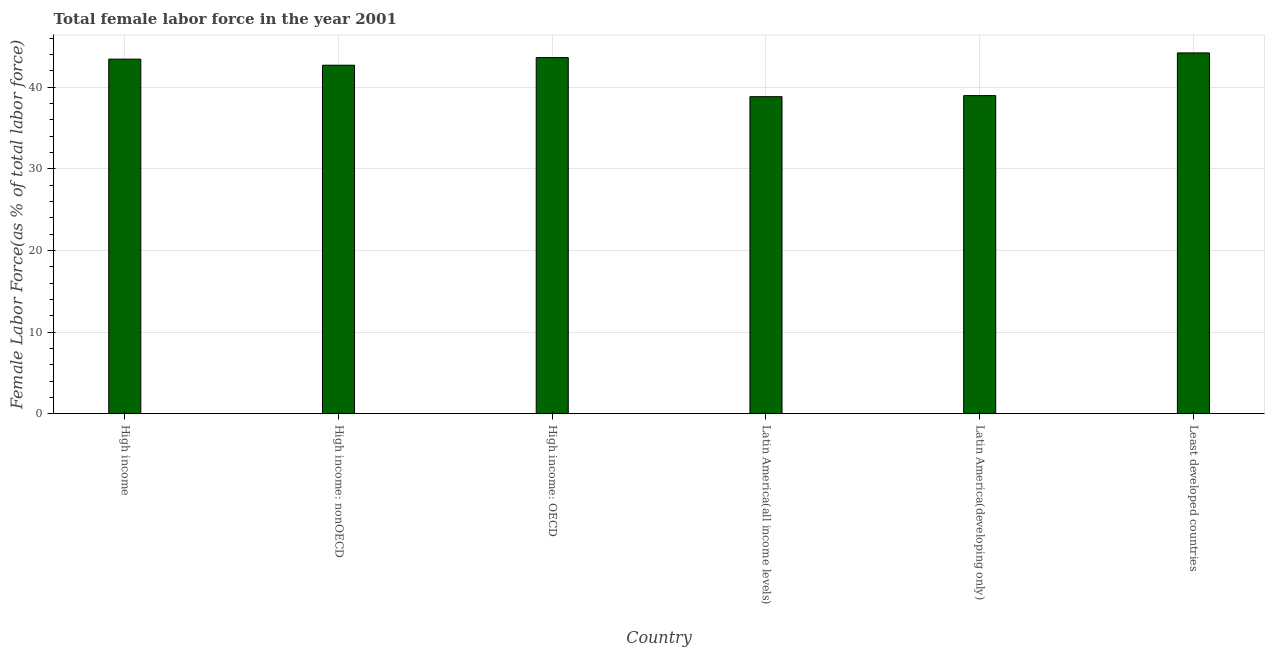Does the graph contain any zero values?
Your answer should be compact. No. What is the title of the graph?
Give a very brief answer. Total female labor force in the year 2001. What is the label or title of the Y-axis?
Provide a short and direct response. Female Labor Force(as % of total labor force). What is the total female labor force in Least developed countries?
Provide a short and direct response. 44.21. Across all countries, what is the maximum total female labor force?
Offer a very short reply. 44.21. Across all countries, what is the minimum total female labor force?
Provide a succinct answer. 38.84. In which country was the total female labor force maximum?
Your answer should be very brief. Least developed countries. In which country was the total female labor force minimum?
Your answer should be very brief. Latin America(all income levels). What is the sum of the total female labor force?
Make the answer very short. 251.8. What is the difference between the total female labor force in High income and Latin America(all income levels)?
Offer a very short reply. 4.6. What is the average total female labor force per country?
Provide a short and direct response. 41.97. What is the median total female labor force?
Make the answer very short. 43.07. Is the difference between the total female labor force in High income and High income: nonOECD greater than the difference between any two countries?
Give a very brief answer. No. What is the difference between the highest and the second highest total female labor force?
Offer a very short reply. 0.57. What is the difference between the highest and the lowest total female labor force?
Provide a short and direct response. 5.36. How many countries are there in the graph?
Offer a terse response. 6. What is the difference between two consecutive major ticks on the Y-axis?
Provide a short and direct response. 10. Are the values on the major ticks of Y-axis written in scientific E-notation?
Your response must be concise. No. What is the Female Labor Force(as % of total labor force) of High income?
Provide a succinct answer. 43.44. What is the Female Labor Force(as % of total labor force) in High income: nonOECD?
Your answer should be compact. 42.7. What is the Female Labor Force(as % of total labor force) of High income: OECD?
Give a very brief answer. 43.63. What is the Female Labor Force(as % of total labor force) of Latin America(all income levels)?
Provide a succinct answer. 38.84. What is the Female Labor Force(as % of total labor force) in Latin America(developing only)?
Give a very brief answer. 38.97. What is the Female Labor Force(as % of total labor force) in Least developed countries?
Ensure brevity in your answer.  44.21. What is the difference between the Female Labor Force(as % of total labor force) in High income and High income: nonOECD?
Offer a very short reply. 0.74. What is the difference between the Female Labor Force(as % of total labor force) in High income and High income: OECD?
Offer a terse response. -0.19. What is the difference between the Female Labor Force(as % of total labor force) in High income and Latin America(all income levels)?
Your response must be concise. 4.6. What is the difference between the Female Labor Force(as % of total labor force) in High income and Latin America(developing only)?
Provide a short and direct response. 4.47. What is the difference between the Female Labor Force(as % of total labor force) in High income and Least developed countries?
Your answer should be very brief. -0.76. What is the difference between the Female Labor Force(as % of total labor force) in High income: nonOECD and High income: OECD?
Your answer should be very brief. -0.93. What is the difference between the Female Labor Force(as % of total labor force) in High income: nonOECD and Latin America(all income levels)?
Offer a terse response. 3.86. What is the difference between the Female Labor Force(as % of total labor force) in High income: nonOECD and Latin America(developing only)?
Ensure brevity in your answer.  3.73. What is the difference between the Female Labor Force(as % of total labor force) in High income: nonOECD and Least developed countries?
Your answer should be compact. -1.51. What is the difference between the Female Labor Force(as % of total labor force) in High income: OECD and Latin America(all income levels)?
Your response must be concise. 4.79. What is the difference between the Female Labor Force(as % of total labor force) in High income: OECD and Latin America(developing only)?
Your answer should be very brief. 4.66. What is the difference between the Female Labor Force(as % of total labor force) in High income: OECD and Least developed countries?
Offer a terse response. -0.57. What is the difference between the Female Labor Force(as % of total labor force) in Latin America(all income levels) and Latin America(developing only)?
Keep it short and to the point. -0.13. What is the difference between the Female Labor Force(as % of total labor force) in Latin America(all income levels) and Least developed countries?
Your answer should be compact. -5.36. What is the difference between the Female Labor Force(as % of total labor force) in Latin America(developing only) and Least developed countries?
Provide a succinct answer. -5.23. What is the ratio of the Female Labor Force(as % of total labor force) in High income to that in High income: nonOECD?
Ensure brevity in your answer.  1.02. What is the ratio of the Female Labor Force(as % of total labor force) in High income to that in Latin America(all income levels)?
Offer a very short reply. 1.12. What is the ratio of the Female Labor Force(as % of total labor force) in High income to that in Latin America(developing only)?
Give a very brief answer. 1.11. What is the ratio of the Female Labor Force(as % of total labor force) in High income: nonOECD to that in High income: OECD?
Give a very brief answer. 0.98. What is the ratio of the Female Labor Force(as % of total labor force) in High income: nonOECD to that in Latin America(all income levels)?
Offer a terse response. 1.1. What is the ratio of the Female Labor Force(as % of total labor force) in High income: nonOECD to that in Latin America(developing only)?
Offer a terse response. 1.1. What is the ratio of the Female Labor Force(as % of total labor force) in High income: nonOECD to that in Least developed countries?
Make the answer very short. 0.97. What is the ratio of the Female Labor Force(as % of total labor force) in High income: OECD to that in Latin America(all income levels)?
Ensure brevity in your answer.  1.12. What is the ratio of the Female Labor Force(as % of total labor force) in High income: OECD to that in Latin America(developing only)?
Your answer should be compact. 1.12. What is the ratio of the Female Labor Force(as % of total labor force) in High income: OECD to that in Least developed countries?
Your answer should be compact. 0.99. What is the ratio of the Female Labor Force(as % of total labor force) in Latin America(all income levels) to that in Least developed countries?
Provide a succinct answer. 0.88. What is the ratio of the Female Labor Force(as % of total labor force) in Latin America(developing only) to that in Least developed countries?
Give a very brief answer. 0.88. 